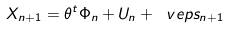<formula> <loc_0><loc_0><loc_500><loc_500>X _ { n + 1 } = \theta ^ { t } \Phi _ { n } + U _ { n } + \ v e p s _ { n + 1 }</formula> 